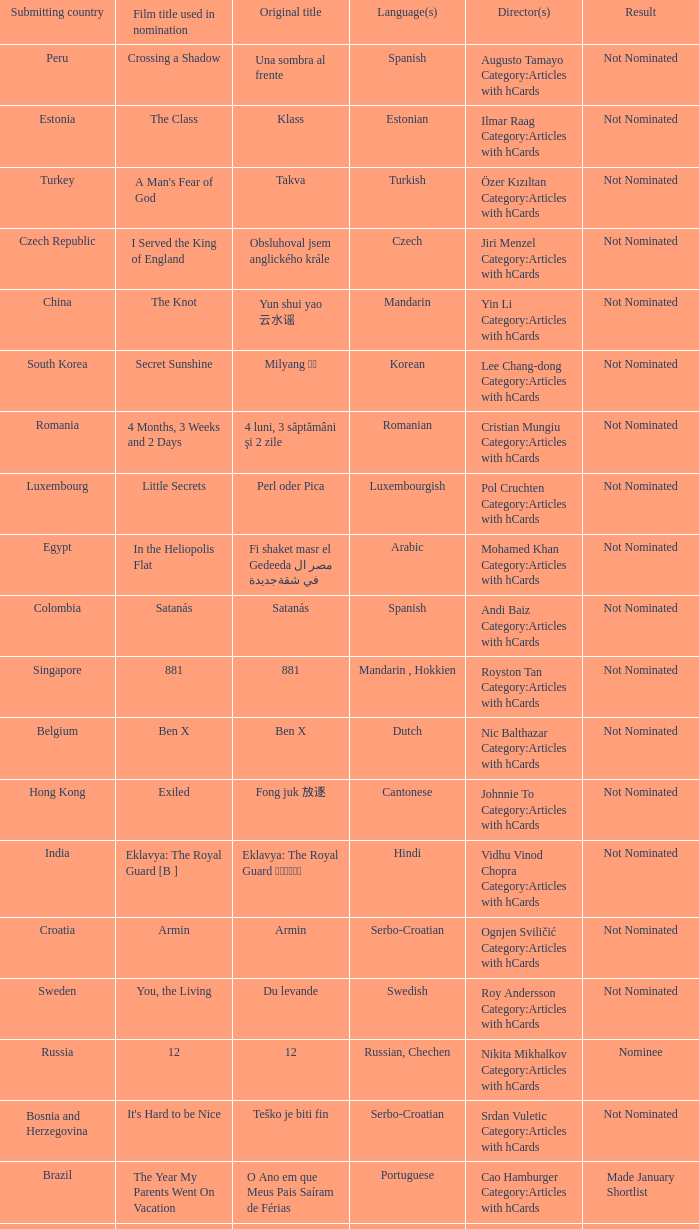What country submitted miehen työ? Finland. 